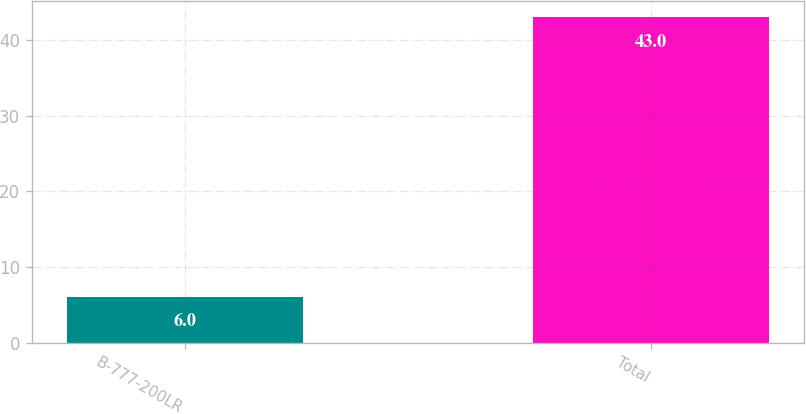<chart> <loc_0><loc_0><loc_500><loc_500><bar_chart><fcel>B-777-200LR<fcel>Total<nl><fcel>6<fcel>43<nl></chart> 